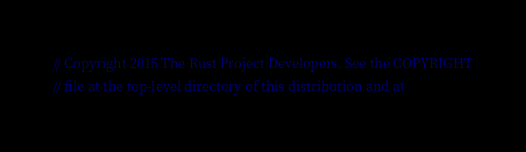<code> <loc_0><loc_0><loc_500><loc_500><_Rust_>// Copyright 2015 The Rust Project Developers. See the COPYRIGHT
// file at the top-level directory of this distribution and at</code> 